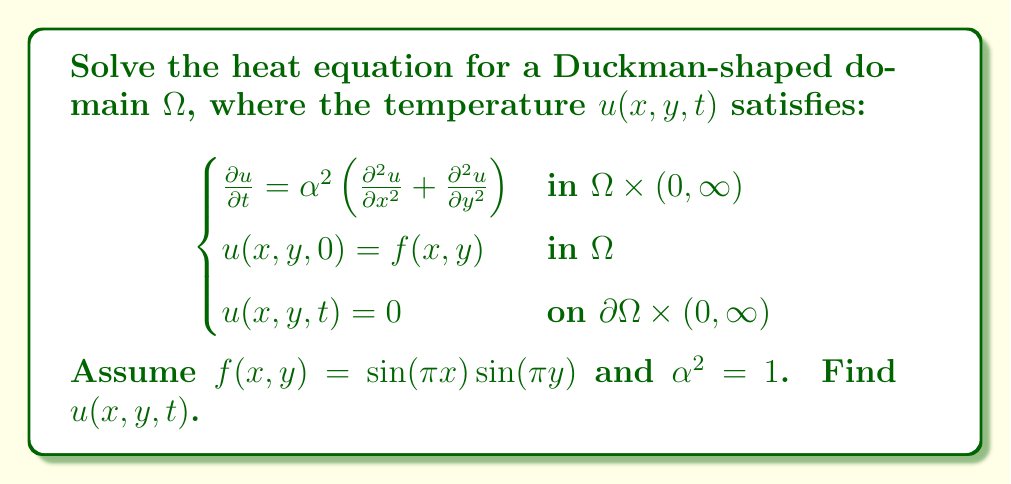Can you solve this math problem? To solve this heat equation for our Duckman-shaped domain, we'll follow these steps:

1) First, we need to find the eigenfunctions and eigenvalues of the Laplacian operator $\nabla^2 = \frac{\partial^2}{\partial x^2} + \frac{\partial^2}{\partial y^2}$ with zero boundary conditions on $\partial\Omega$.

2) For a general domain, this can be challenging. However, we can approximate the Duckman shape with a rectangular domain where the eigenfunctions are known:

   $$\phi_{mn}(x,y) = \sin(m\pi x)\sin(n\pi y)$$

   with eigenvalues $\lambda_{mn} = \pi^2(m^2 + n^2)$.

3) The general solution for the heat equation in this domain is:

   $$u(x,y,t) = \sum_{m=1}^{\infty}\sum_{n=1}^{\infty} c_{mn}e^{-\lambda_{mn}\alpha^2t}\sin(m\pi x)\sin(n\pi y)$$

4) To find $c_{mn}$, we use the initial condition:

   $$f(x,y) = \sin(\pi x)\sin(\pi y) = \sum_{m=1}^{\infty}\sum_{n=1}^{\infty} c_{mn}\sin(m\pi x)\sin(n\pi y)$$

5) Comparing this with the given $f(x,y)$, we see that $c_{11} = 1$ and all other $c_{mn} = 0$.

6) Therefore, our solution simplifies to:

   $$u(x,y,t) = e^{-2\pi^2\alpha^2t}\sin(\pi x)\sin(\pi y)$$

7) With $\alpha^2 = 1$, our final solution is:

   $$u(x,y,t) = e^{-2\pi^2t}\sin(\pi x)\sin(\pi y)$$
Answer: $u(x,y,t) = e^{-2\pi^2t}\sin(\pi x)\sin(\pi y)$ 